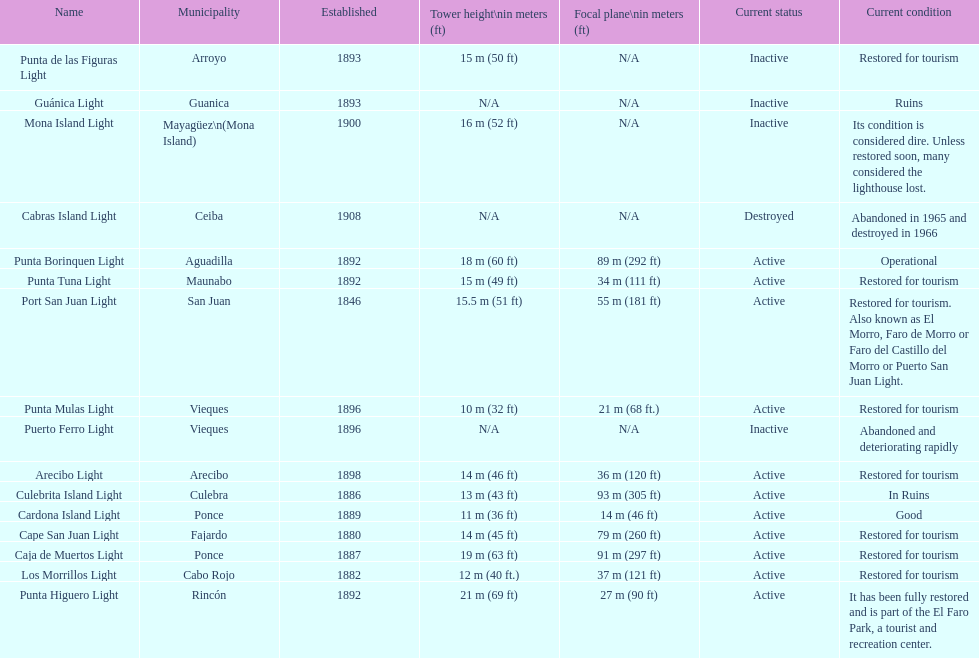Names of municipalities established before 1880 San Juan. 